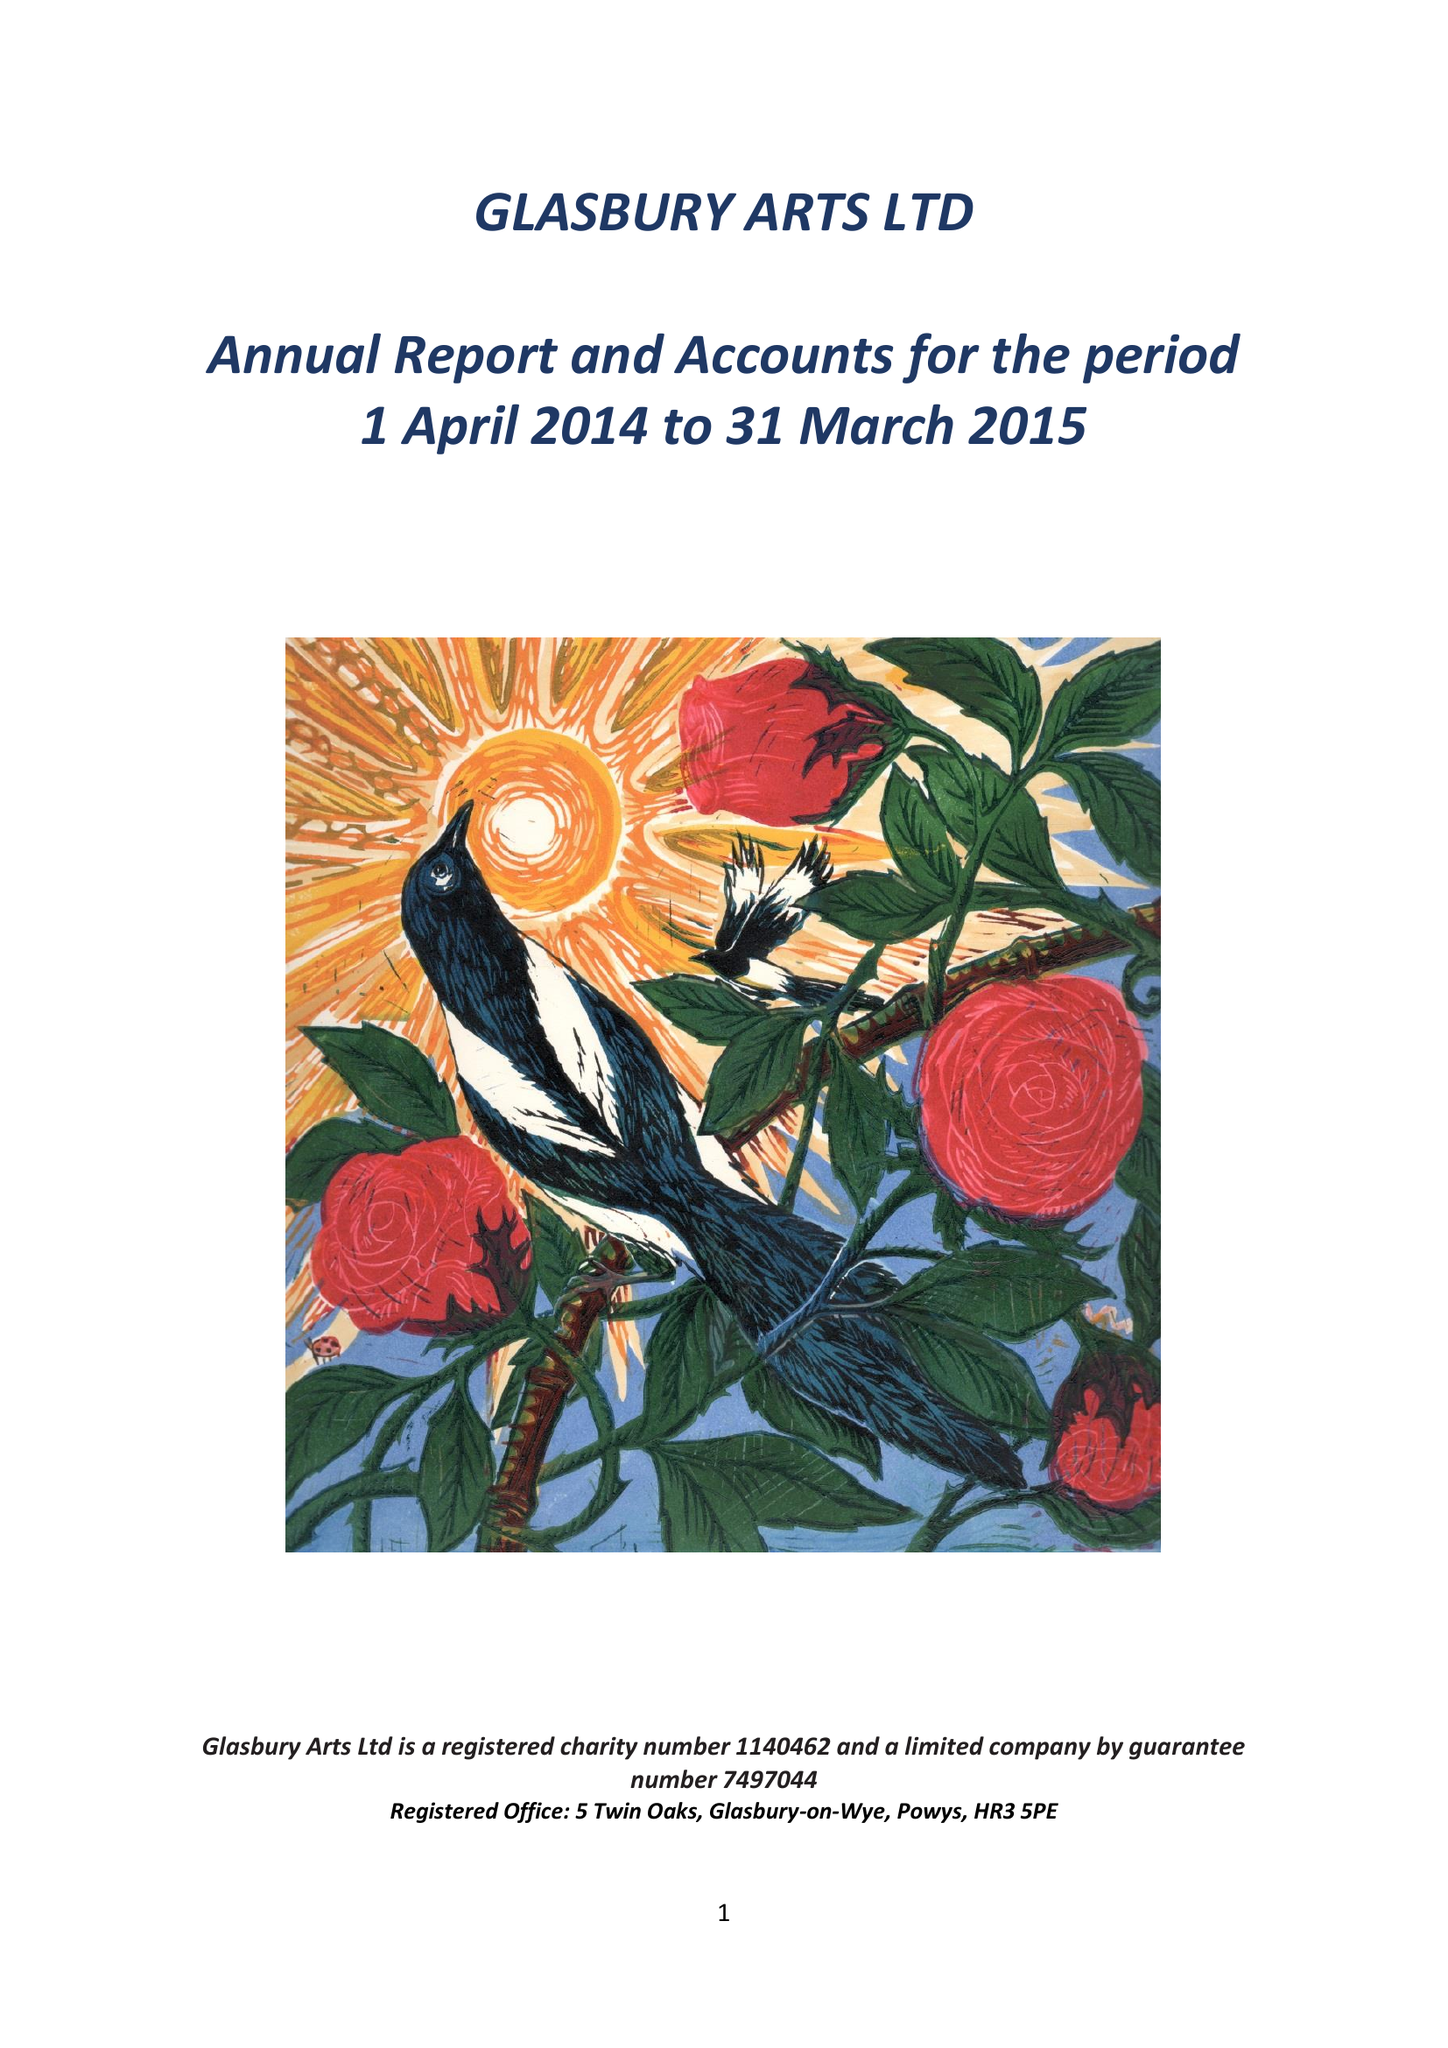What is the value for the income_annually_in_british_pounds?
Answer the question using a single word or phrase. 25461.00 